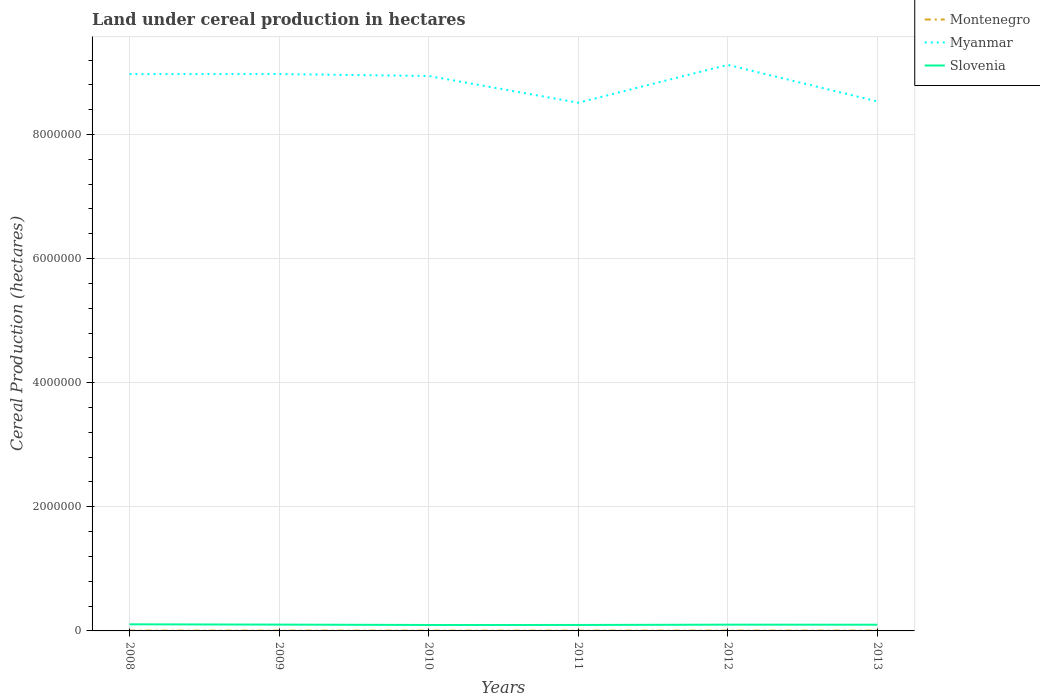How many different coloured lines are there?
Your response must be concise. 3. Does the line corresponding to Montenegro intersect with the line corresponding to Slovenia?
Ensure brevity in your answer.  No. Across all years, what is the maximum land under cereal production in Montenegro?
Offer a terse response. 4653. In which year was the land under cereal production in Myanmar maximum?
Ensure brevity in your answer.  2011. What is the total land under cereal production in Slovenia in the graph?
Your response must be concise. -221. What is the difference between the highest and the second highest land under cereal production in Montenegro?
Offer a terse response. 217. Is the land under cereal production in Myanmar strictly greater than the land under cereal production in Slovenia over the years?
Keep it short and to the point. No. What is the difference between two consecutive major ticks on the Y-axis?
Offer a very short reply. 2.00e+06. Where does the legend appear in the graph?
Ensure brevity in your answer.  Top right. What is the title of the graph?
Give a very brief answer. Land under cereal production in hectares. Does "Philippines" appear as one of the legend labels in the graph?
Your answer should be compact. No. What is the label or title of the Y-axis?
Provide a succinct answer. Cereal Production (hectares). What is the Cereal Production (hectares) of Montenegro in 2008?
Provide a short and direct response. 4746. What is the Cereal Production (hectares) in Myanmar in 2008?
Provide a succinct answer. 8.97e+06. What is the Cereal Production (hectares) in Slovenia in 2008?
Your answer should be compact. 1.07e+05. What is the Cereal Production (hectares) of Montenegro in 2009?
Offer a terse response. 4841. What is the Cereal Production (hectares) in Myanmar in 2009?
Provide a short and direct response. 8.97e+06. What is the Cereal Production (hectares) in Slovenia in 2009?
Keep it short and to the point. 1.02e+05. What is the Cereal Production (hectares) of Montenegro in 2010?
Make the answer very short. 4653. What is the Cereal Production (hectares) of Myanmar in 2010?
Offer a terse response. 8.94e+06. What is the Cereal Production (hectares) of Slovenia in 2010?
Provide a short and direct response. 9.57e+04. What is the Cereal Production (hectares) of Montenegro in 2011?
Give a very brief answer. 4795. What is the Cereal Production (hectares) in Myanmar in 2011?
Offer a terse response. 8.51e+06. What is the Cereal Production (hectares) in Slovenia in 2011?
Ensure brevity in your answer.  9.59e+04. What is the Cereal Production (hectares) in Montenegro in 2012?
Your response must be concise. 4656. What is the Cereal Production (hectares) in Myanmar in 2012?
Your answer should be compact. 9.12e+06. What is the Cereal Production (hectares) in Slovenia in 2012?
Your answer should be very brief. 1.01e+05. What is the Cereal Production (hectares) in Montenegro in 2013?
Keep it short and to the point. 4870. What is the Cereal Production (hectares) of Myanmar in 2013?
Make the answer very short. 8.53e+06. What is the Cereal Production (hectares) in Slovenia in 2013?
Make the answer very short. 1.00e+05. Across all years, what is the maximum Cereal Production (hectares) of Montenegro?
Your answer should be compact. 4870. Across all years, what is the maximum Cereal Production (hectares) of Myanmar?
Offer a very short reply. 9.12e+06. Across all years, what is the maximum Cereal Production (hectares) of Slovenia?
Your answer should be compact. 1.07e+05. Across all years, what is the minimum Cereal Production (hectares) of Montenegro?
Provide a short and direct response. 4653. Across all years, what is the minimum Cereal Production (hectares) in Myanmar?
Make the answer very short. 8.51e+06. Across all years, what is the minimum Cereal Production (hectares) of Slovenia?
Your answer should be compact. 9.57e+04. What is the total Cereal Production (hectares) of Montenegro in the graph?
Provide a succinct answer. 2.86e+04. What is the total Cereal Production (hectares) in Myanmar in the graph?
Offer a very short reply. 5.31e+07. What is the total Cereal Production (hectares) of Slovenia in the graph?
Your answer should be very brief. 6.01e+05. What is the difference between the Cereal Production (hectares) of Montenegro in 2008 and that in 2009?
Make the answer very short. -95. What is the difference between the Cereal Production (hectares) in Myanmar in 2008 and that in 2009?
Your response must be concise. -1142. What is the difference between the Cereal Production (hectares) of Slovenia in 2008 and that in 2009?
Make the answer very short. 4742. What is the difference between the Cereal Production (hectares) of Montenegro in 2008 and that in 2010?
Keep it short and to the point. 93. What is the difference between the Cereal Production (hectares) of Myanmar in 2008 and that in 2010?
Offer a very short reply. 2.97e+04. What is the difference between the Cereal Production (hectares) of Slovenia in 2008 and that in 2010?
Your response must be concise. 1.09e+04. What is the difference between the Cereal Production (hectares) in Montenegro in 2008 and that in 2011?
Offer a terse response. -49. What is the difference between the Cereal Production (hectares) in Myanmar in 2008 and that in 2011?
Your answer should be very brief. 4.61e+05. What is the difference between the Cereal Production (hectares) in Slovenia in 2008 and that in 2011?
Provide a succinct answer. 1.07e+04. What is the difference between the Cereal Production (hectares) of Montenegro in 2008 and that in 2012?
Provide a short and direct response. 90. What is the difference between the Cereal Production (hectares) in Myanmar in 2008 and that in 2012?
Your answer should be very brief. -1.49e+05. What is the difference between the Cereal Production (hectares) of Slovenia in 2008 and that in 2012?
Your response must be concise. 5840. What is the difference between the Cereal Production (hectares) in Montenegro in 2008 and that in 2013?
Give a very brief answer. -124. What is the difference between the Cereal Production (hectares) of Myanmar in 2008 and that in 2013?
Provide a short and direct response. 4.40e+05. What is the difference between the Cereal Production (hectares) in Slovenia in 2008 and that in 2013?
Offer a terse response. 6602. What is the difference between the Cereal Production (hectares) of Montenegro in 2009 and that in 2010?
Your response must be concise. 188. What is the difference between the Cereal Production (hectares) in Myanmar in 2009 and that in 2010?
Your answer should be compact. 3.08e+04. What is the difference between the Cereal Production (hectares) of Slovenia in 2009 and that in 2010?
Give a very brief answer. 6165. What is the difference between the Cereal Production (hectares) in Montenegro in 2009 and that in 2011?
Offer a very short reply. 46. What is the difference between the Cereal Production (hectares) of Myanmar in 2009 and that in 2011?
Keep it short and to the point. 4.62e+05. What is the difference between the Cereal Production (hectares) of Slovenia in 2009 and that in 2011?
Ensure brevity in your answer.  5944. What is the difference between the Cereal Production (hectares) of Montenegro in 2009 and that in 2012?
Your answer should be very brief. 185. What is the difference between the Cereal Production (hectares) in Myanmar in 2009 and that in 2012?
Your response must be concise. -1.48e+05. What is the difference between the Cereal Production (hectares) of Slovenia in 2009 and that in 2012?
Provide a succinct answer. 1098. What is the difference between the Cereal Production (hectares) in Myanmar in 2009 and that in 2013?
Your answer should be very brief. 4.41e+05. What is the difference between the Cereal Production (hectares) of Slovenia in 2009 and that in 2013?
Your answer should be compact. 1860. What is the difference between the Cereal Production (hectares) of Montenegro in 2010 and that in 2011?
Make the answer very short. -142. What is the difference between the Cereal Production (hectares) in Myanmar in 2010 and that in 2011?
Provide a short and direct response. 4.31e+05. What is the difference between the Cereal Production (hectares) in Slovenia in 2010 and that in 2011?
Your response must be concise. -221. What is the difference between the Cereal Production (hectares) of Montenegro in 2010 and that in 2012?
Keep it short and to the point. -3. What is the difference between the Cereal Production (hectares) in Myanmar in 2010 and that in 2012?
Offer a very short reply. -1.79e+05. What is the difference between the Cereal Production (hectares) in Slovenia in 2010 and that in 2012?
Ensure brevity in your answer.  -5067. What is the difference between the Cereal Production (hectares) of Montenegro in 2010 and that in 2013?
Your response must be concise. -217. What is the difference between the Cereal Production (hectares) of Myanmar in 2010 and that in 2013?
Provide a short and direct response. 4.10e+05. What is the difference between the Cereal Production (hectares) of Slovenia in 2010 and that in 2013?
Offer a very short reply. -4305. What is the difference between the Cereal Production (hectares) in Montenegro in 2011 and that in 2012?
Provide a succinct answer. 139. What is the difference between the Cereal Production (hectares) in Myanmar in 2011 and that in 2012?
Your answer should be compact. -6.10e+05. What is the difference between the Cereal Production (hectares) in Slovenia in 2011 and that in 2012?
Your answer should be very brief. -4846. What is the difference between the Cereal Production (hectares) of Montenegro in 2011 and that in 2013?
Provide a succinct answer. -75. What is the difference between the Cereal Production (hectares) of Myanmar in 2011 and that in 2013?
Make the answer very short. -2.06e+04. What is the difference between the Cereal Production (hectares) of Slovenia in 2011 and that in 2013?
Your answer should be very brief. -4084. What is the difference between the Cereal Production (hectares) of Montenegro in 2012 and that in 2013?
Keep it short and to the point. -214. What is the difference between the Cereal Production (hectares) of Myanmar in 2012 and that in 2013?
Your answer should be compact. 5.90e+05. What is the difference between the Cereal Production (hectares) in Slovenia in 2012 and that in 2013?
Give a very brief answer. 762. What is the difference between the Cereal Production (hectares) of Montenegro in 2008 and the Cereal Production (hectares) of Myanmar in 2009?
Your answer should be compact. -8.97e+06. What is the difference between the Cereal Production (hectares) in Montenegro in 2008 and the Cereal Production (hectares) in Slovenia in 2009?
Your answer should be very brief. -9.71e+04. What is the difference between the Cereal Production (hectares) in Myanmar in 2008 and the Cereal Production (hectares) in Slovenia in 2009?
Your response must be concise. 8.87e+06. What is the difference between the Cereal Production (hectares) of Montenegro in 2008 and the Cereal Production (hectares) of Myanmar in 2010?
Offer a very short reply. -8.94e+06. What is the difference between the Cereal Production (hectares) of Montenegro in 2008 and the Cereal Production (hectares) of Slovenia in 2010?
Give a very brief answer. -9.09e+04. What is the difference between the Cereal Production (hectares) in Myanmar in 2008 and the Cereal Production (hectares) in Slovenia in 2010?
Your answer should be very brief. 8.88e+06. What is the difference between the Cereal Production (hectares) in Montenegro in 2008 and the Cereal Production (hectares) in Myanmar in 2011?
Provide a succinct answer. -8.51e+06. What is the difference between the Cereal Production (hectares) in Montenegro in 2008 and the Cereal Production (hectares) in Slovenia in 2011?
Offer a very short reply. -9.11e+04. What is the difference between the Cereal Production (hectares) of Myanmar in 2008 and the Cereal Production (hectares) of Slovenia in 2011?
Ensure brevity in your answer.  8.88e+06. What is the difference between the Cereal Production (hectares) of Montenegro in 2008 and the Cereal Production (hectares) of Myanmar in 2012?
Keep it short and to the point. -9.12e+06. What is the difference between the Cereal Production (hectares) in Montenegro in 2008 and the Cereal Production (hectares) in Slovenia in 2012?
Your response must be concise. -9.60e+04. What is the difference between the Cereal Production (hectares) in Myanmar in 2008 and the Cereal Production (hectares) in Slovenia in 2012?
Ensure brevity in your answer.  8.87e+06. What is the difference between the Cereal Production (hectares) of Montenegro in 2008 and the Cereal Production (hectares) of Myanmar in 2013?
Provide a short and direct response. -8.53e+06. What is the difference between the Cereal Production (hectares) of Montenegro in 2008 and the Cereal Production (hectares) of Slovenia in 2013?
Your answer should be compact. -9.52e+04. What is the difference between the Cereal Production (hectares) of Myanmar in 2008 and the Cereal Production (hectares) of Slovenia in 2013?
Offer a very short reply. 8.87e+06. What is the difference between the Cereal Production (hectares) of Montenegro in 2009 and the Cereal Production (hectares) of Myanmar in 2010?
Ensure brevity in your answer.  -8.94e+06. What is the difference between the Cereal Production (hectares) in Montenegro in 2009 and the Cereal Production (hectares) in Slovenia in 2010?
Keep it short and to the point. -9.08e+04. What is the difference between the Cereal Production (hectares) in Myanmar in 2009 and the Cereal Production (hectares) in Slovenia in 2010?
Ensure brevity in your answer.  8.88e+06. What is the difference between the Cereal Production (hectares) in Montenegro in 2009 and the Cereal Production (hectares) in Myanmar in 2011?
Provide a short and direct response. -8.51e+06. What is the difference between the Cereal Production (hectares) of Montenegro in 2009 and the Cereal Production (hectares) of Slovenia in 2011?
Your answer should be compact. -9.10e+04. What is the difference between the Cereal Production (hectares) of Myanmar in 2009 and the Cereal Production (hectares) of Slovenia in 2011?
Offer a terse response. 8.88e+06. What is the difference between the Cereal Production (hectares) of Montenegro in 2009 and the Cereal Production (hectares) of Myanmar in 2012?
Make the answer very short. -9.12e+06. What is the difference between the Cereal Production (hectares) of Montenegro in 2009 and the Cereal Production (hectares) of Slovenia in 2012?
Keep it short and to the point. -9.59e+04. What is the difference between the Cereal Production (hectares) in Myanmar in 2009 and the Cereal Production (hectares) in Slovenia in 2012?
Your response must be concise. 8.87e+06. What is the difference between the Cereal Production (hectares) in Montenegro in 2009 and the Cereal Production (hectares) in Myanmar in 2013?
Offer a terse response. -8.53e+06. What is the difference between the Cereal Production (hectares) of Montenegro in 2009 and the Cereal Production (hectares) of Slovenia in 2013?
Provide a succinct answer. -9.51e+04. What is the difference between the Cereal Production (hectares) in Myanmar in 2009 and the Cereal Production (hectares) in Slovenia in 2013?
Offer a very short reply. 8.87e+06. What is the difference between the Cereal Production (hectares) in Montenegro in 2010 and the Cereal Production (hectares) in Myanmar in 2011?
Your answer should be compact. -8.51e+06. What is the difference between the Cereal Production (hectares) of Montenegro in 2010 and the Cereal Production (hectares) of Slovenia in 2011?
Make the answer very short. -9.12e+04. What is the difference between the Cereal Production (hectares) in Myanmar in 2010 and the Cereal Production (hectares) in Slovenia in 2011?
Make the answer very short. 8.85e+06. What is the difference between the Cereal Production (hectares) in Montenegro in 2010 and the Cereal Production (hectares) in Myanmar in 2012?
Provide a succinct answer. -9.12e+06. What is the difference between the Cereal Production (hectares) of Montenegro in 2010 and the Cereal Production (hectares) of Slovenia in 2012?
Keep it short and to the point. -9.61e+04. What is the difference between the Cereal Production (hectares) of Myanmar in 2010 and the Cereal Production (hectares) of Slovenia in 2012?
Offer a very short reply. 8.84e+06. What is the difference between the Cereal Production (hectares) in Montenegro in 2010 and the Cereal Production (hectares) in Myanmar in 2013?
Offer a terse response. -8.53e+06. What is the difference between the Cereal Production (hectares) in Montenegro in 2010 and the Cereal Production (hectares) in Slovenia in 2013?
Your response must be concise. -9.53e+04. What is the difference between the Cereal Production (hectares) in Myanmar in 2010 and the Cereal Production (hectares) in Slovenia in 2013?
Give a very brief answer. 8.84e+06. What is the difference between the Cereal Production (hectares) of Montenegro in 2011 and the Cereal Production (hectares) of Myanmar in 2012?
Ensure brevity in your answer.  -9.12e+06. What is the difference between the Cereal Production (hectares) in Montenegro in 2011 and the Cereal Production (hectares) in Slovenia in 2012?
Ensure brevity in your answer.  -9.59e+04. What is the difference between the Cereal Production (hectares) of Myanmar in 2011 and the Cereal Production (hectares) of Slovenia in 2012?
Offer a terse response. 8.41e+06. What is the difference between the Cereal Production (hectares) in Montenegro in 2011 and the Cereal Production (hectares) in Myanmar in 2013?
Ensure brevity in your answer.  -8.53e+06. What is the difference between the Cereal Production (hectares) of Montenegro in 2011 and the Cereal Production (hectares) of Slovenia in 2013?
Offer a terse response. -9.52e+04. What is the difference between the Cereal Production (hectares) of Myanmar in 2011 and the Cereal Production (hectares) of Slovenia in 2013?
Your answer should be very brief. 8.41e+06. What is the difference between the Cereal Production (hectares) of Montenegro in 2012 and the Cereal Production (hectares) of Myanmar in 2013?
Offer a very short reply. -8.53e+06. What is the difference between the Cereal Production (hectares) in Montenegro in 2012 and the Cereal Production (hectares) in Slovenia in 2013?
Ensure brevity in your answer.  -9.53e+04. What is the difference between the Cereal Production (hectares) in Myanmar in 2012 and the Cereal Production (hectares) in Slovenia in 2013?
Ensure brevity in your answer.  9.02e+06. What is the average Cereal Production (hectares) of Montenegro per year?
Offer a very short reply. 4760.17. What is the average Cereal Production (hectares) of Myanmar per year?
Your answer should be compact. 8.84e+06. What is the average Cereal Production (hectares) in Slovenia per year?
Your answer should be very brief. 1.00e+05. In the year 2008, what is the difference between the Cereal Production (hectares) in Montenegro and Cereal Production (hectares) in Myanmar?
Your response must be concise. -8.97e+06. In the year 2008, what is the difference between the Cereal Production (hectares) in Montenegro and Cereal Production (hectares) in Slovenia?
Keep it short and to the point. -1.02e+05. In the year 2008, what is the difference between the Cereal Production (hectares) of Myanmar and Cereal Production (hectares) of Slovenia?
Make the answer very short. 8.87e+06. In the year 2009, what is the difference between the Cereal Production (hectares) in Montenegro and Cereal Production (hectares) in Myanmar?
Make the answer very short. -8.97e+06. In the year 2009, what is the difference between the Cereal Production (hectares) in Montenegro and Cereal Production (hectares) in Slovenia?
Make the answer very short. -9.70e+04. In the year 2009, what is the difference between the Cereal Production (hectares) in Myanmar and Cereal Production (hectares) in Slovenia?
Offer a very short reply. 8.87e+06. In the year 2010, what is the difference between the Cereal Production (hectares) of Montenegro and Cereal Production (hectares) of Myanmar?
Provide a short and direct response. -8.94e+06. In the year 2010, what is the difference between the Cereal Production (hectares) of Montenegro and Cereal Production (hectares) of Slovenia?
Your answer should be very brief. -9.10e+04. In the year 2010, what is the difference between the Cereal Production (hectares) of Myanmar and Cereal Production (hectares) of Slovenia?
Offer a terse response. 8.85e+06. In the year 2011, what is the difference between the Cereal Production (hectares) in Montenegro and Cereal Production (hectares) in Myanmar?
Make the answer very short. -8.51e+06. In the year 2011, what is the difference between the Cereal Production (hectares) in Montenegro and Cereal Production (hectares) in Slovenia?
Keep it short and to the point. -9.11e+04. In the year 2011, what is the difference between the Cereal Production (hectares) of Myanmar and Cereal Production (hectares) of Slovenia?
Give a very brief answer. 8.42e+06. In the year 2012, what is the difference between the Cereal Production (hectares) in Montenegro and Cereal Production (hectares) in Myanmar?
Give a very brief answer. -9.12e+06. In the year 2012, what is the difference between the Cereal Production (hectares) of Montenegro and Cereal Production (hectares) of Slovenia?
Keep it short and to the point. -9.61e+04. In the year 2012, what is the difference between the Cereal Production (hectares) of Myanmar and Cereal Production (hectares) of Slovenia?
Make the answer very short. 9.02e+06. In the year 2013, what is the difference between the Cereal Production (hectares) of Montenegro and Cereal Production (hectares) of Myanmar?
Offer a very short reply. -8.53e+06. In the year 2013, what is the difference between the Cereal Production (hectares) of Montenegro and Cereal Production (hectares) of Slovenia?
Offer a very short reply. -9.51e+04. In the year 2013, what is the difference between the Cereal Production (hectares) in Myanmar and Cereal Production (hectares) in Slovenia?
Your answer should be compact. 8.43e+06. What is the ratio of the Cereal Production (hectares) of Montenegro in 2008 to that in 2009?
Provide a short and direct response. 0.98. What is the ratio of the Cereal Production (hectares) of Slovenia in 2008 to that in 2009?
Make the answer very short. 1.05. What is the ratio of the Cereal Production (hectares) of Montenegro in 2008 to that in 2010?
Provide a short and direct response. 1.02. What is the ratio of the Cereal Production (hectares) in Slovenia in 2008 to that in 2010?
Offer a terse response. 1.11. What is the ratio of the Cereal Production (hectares) in Montenegro in 2008 to that in 2011?
Give a very brief answer. 0.99. What is the ratio of the Cereal Production (hectares) of Myanmar in 2008 to that in 2011?
Keep it short and to the point. 1.05. What is the ratio of the Cereal Production (hectares) in Slovenia in 2008 to that in 2011?
Your answer should be compact. 1.11. What is the ratio of the Cereal Production (hectares) of Montenegro in 2008 to that in 2012?
Ensure brevity in your answer.  1.02. What is the ratio of the Cereal Production (hectares) in Myanmar in 2008 to that in 2012?
Offer a very short reply. 0.98. What is the ratio of the Cereal Production (hectares) in Slovenia in 2008 to that in 2012?
Make the answer very short. 1.06. What is the ratio of the Cereal Production (hectares) of Montenegro in 2008 to that in 2013?
Your answer should be very brief. 0.97. What is the ratio of the Cereal Production (hectares) of Myanmar in 2008 to that in 2013?
Your response must be concise. 1.05. What is the ratio of the Cereal Production (hectares) in Slovenia in 2008 to that in 2013?
Your response must be concise. 1.07. What is the ratio of the Cereal Production (hectares) in Montenegro in 2009 to that in 2010?
Your answer should be compact. 1.04. What is the ratio of the Cereal Production (hectares) of Slovenia in 2009 to that in 2010?
Give a very brief answer. 1.06. What is the ratio of the Cereal Production (hectares) in Montenegro in 2009 to that in 2011?
Provide a succinct answer. 1.01. What is the ratio of the Cereal Production (hectares) of Myanmar in 2009 to that in 2011?
Ensure brevity in your answer.  1.05. What is the ratio of the Cereal Production (hectares) in Slovenia in 2009 to that in 2011?
Keep it short and to the point. 1.06. What is the ratio of the Cereal Production (hectares) of Montenegro in 2009 to that in 2012?
Your answer should be compact. 1.04. What is the ratio of the Cereal Production (hectares) of Myanmar in 2009 to that in 2012?
Offer a terse response. 0.98. What is the ratio of the Cereal Production (hectares) of Slovenia in 2009 to that in 2012?
Give a very brief answer. 1.01. What is the ratio of the Cereal Production (hectares) in Myanmar in 2009 to that in 2013?
Your answer should be compact. 1.05. What is the ratio of the Cereal Production (hectares) in Slovenia in 2009 to that in 2013?
Ensure brevity in your answer.  1.02. What is the ratio of the Cereal Production (hectares) in Montenegro in 2010 to that in 2011?
Your response must be concise. 0.97. What is the ratio of the Cereal Production (hectares) of Myanmar in 2010 to that in 2011?
Your response must be concise. 1.05. What is the ratio of the Cereal Production (hectares) in Montenegro in 2010 to that in 2012?
Keep it short and to the point. 1. What is the ratio of the Cereal Production (hectares) of Myanmar in 2010 to that in 2012?
Your answer should be compact. 0.98. What is the ratio of the Cereal Production (hectares) of Slovenia in 2010 to that in 2012?
Provide a short and direct response. 0.95. What is the ratio of the Cereal Production (hectares) in Montenegro in 2010 to that in 2013?
Offer a very short reply. 0.96. What is the ratio of the Cereal Production (hectares) of Myanmar in 2010 to that in 2013?
Your response must be concise. 1.05. What is the ratio of the Cereal Production (hectares) of Slovenia in 2010 to that in 2013?
Give a very brief answer. 0.96. What is the ratio of the Cereal Production (hectares) in Montenegro in 2011 to that in 2012?
Ensure brevity in your answer.  1.03. What is the ratio of the Cereal Production (hectares) in Myanmar in 2011 to that in 2012?
Provide a short and direct response. 0.93. What is the ratio of the Cereal Production (hectares) of Slovenia in 2011 to that in 2012?
Your answer should be very brief. 0.95. What is the ratio of the Cereal Production (hectares) in Montenegro in 2011 to that in 2013?
Give a very brief answer. 0.98. What is the ratio of the Cereal Production (hectares) of Myanmar in 2011 to that in 2013?
Offer a very short reply. 1. What is the ratio of the Cereal Production (hectares) in Slovenia in 2011 to that in 2013?
Provide a short and direct response. 0.96. What is the ratio of the Cereal Production (hectares) in Montenegro in 2012 to that in 2013?
Give a very brief answer. 0.96. What is the ratio of the Cereal Production (hectares) in Myanmar in 2012 to that in 2013?
Offer a terse response. 1.07. What is the ratio of the Cereal Production (hectares) in Slovenia in 2012 to that in 2013?
Ensure brevity in your answer.  1.01. What is the difference between the highest and the second highest Cereal Production (hectares) in Montenegro?
Offer a terse response. 29. What is the difference between the highest and the second highest Cereal Production (hectares) of Myanmar?
Make the answer very short. 1.48e+05. What is the difference between the highest and the second highest Cereal Production (hectares) of Slovenia?
Provide a succinct answer. 4742. What is the difference between the highest and the lowest Cereal Production (hectares) in Montenegro?
Give a very brief answer. 217. What is the difference between the highest and the lowest Cereal Production (hectares) of Myanmar?
Provide a succinct answer. 6.10e+05. What is the difference between the highest and the lowest Cereal Production (hectares) of Slovenia?
Your answer should be compact. 1.09e+04. 